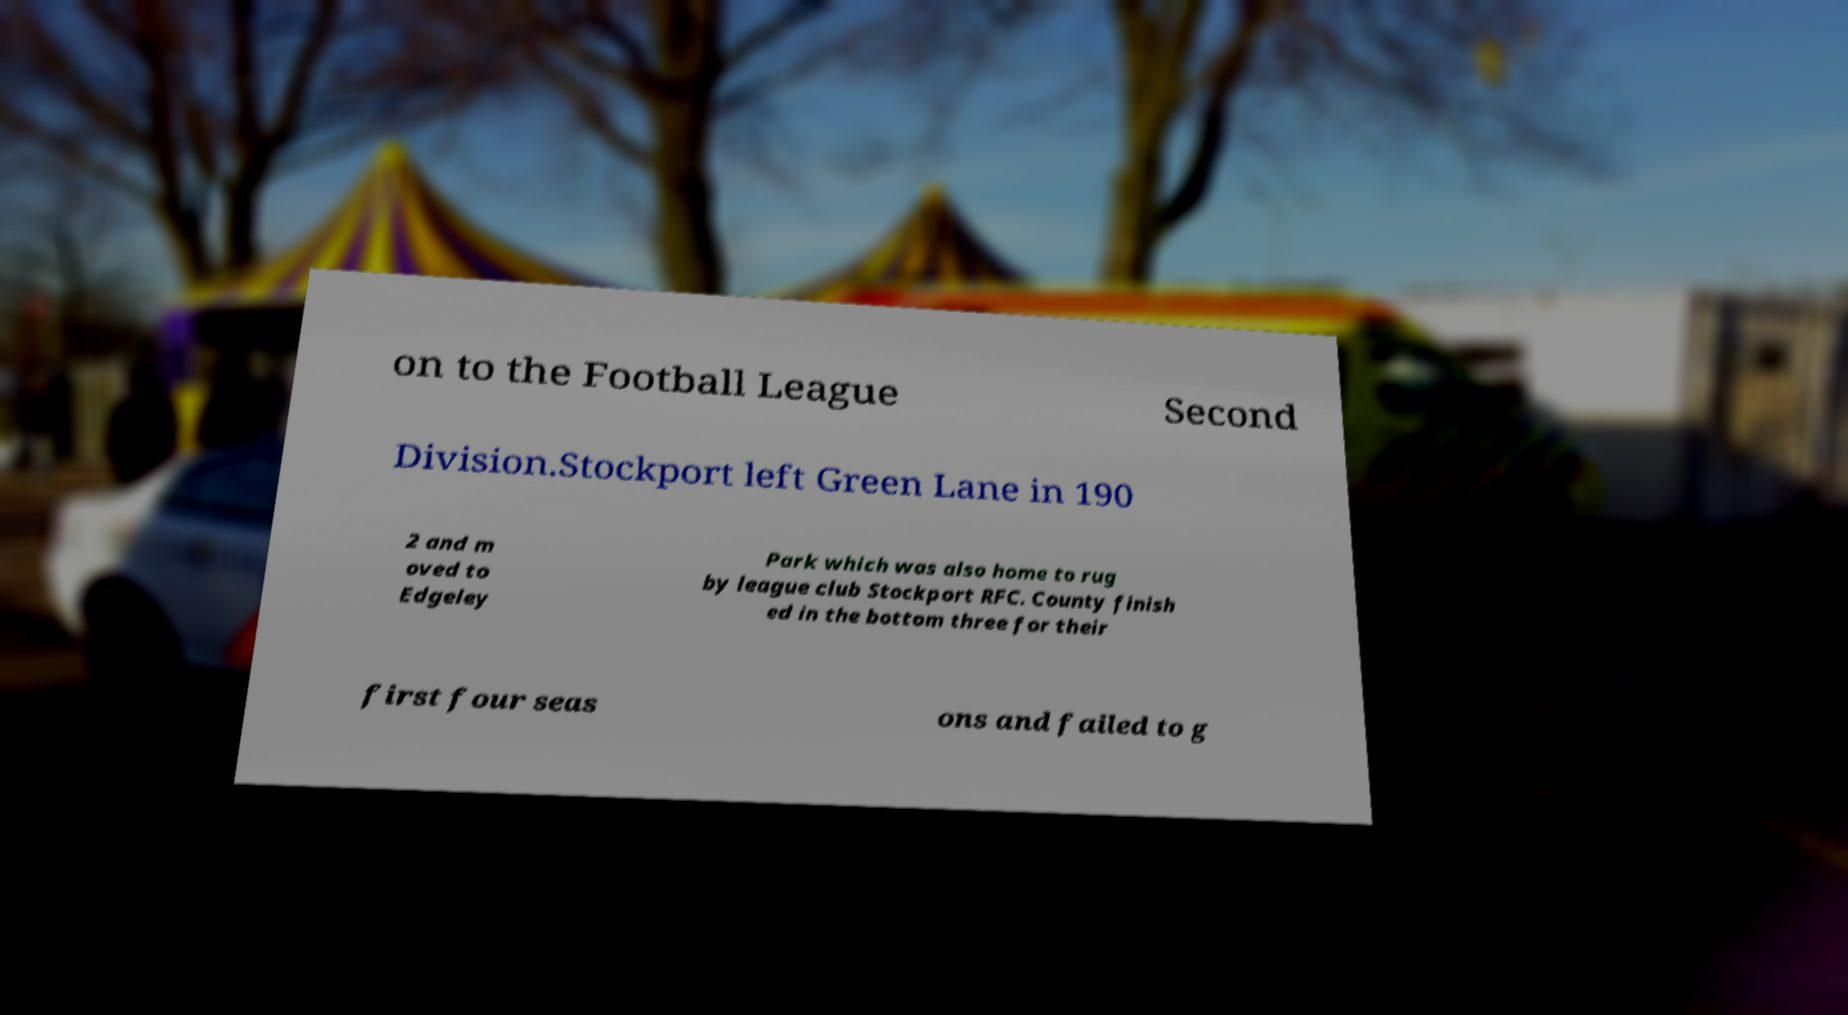Can you read and provide the text displayed in the image?This photo seems to have some interesting text. Can you extract and type it out for me? on to the Football League Second Division.Stockport left Green Lane in 190 2 and m oved to Edgeley Park which was also home to rug by league club Stockport RFC. County finish ed in the bottom three for their first four seas ons and failed to g 